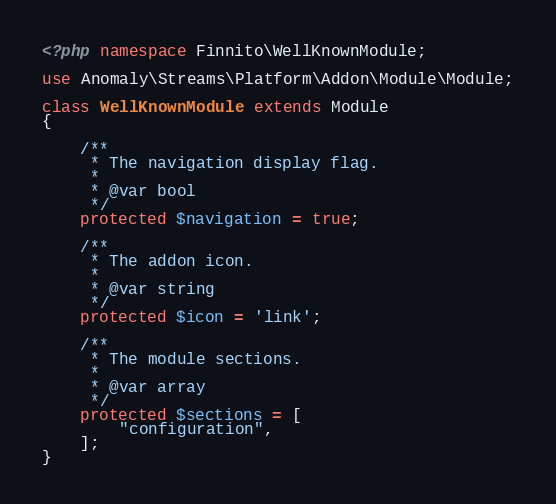Convert code to text. <code><loc_0><loc_0><loc_500><loc_500><_PHP_><?php namespace Finnito\WellKnownModule;

use Anomaly\Streams\Platform\Addon\Module\Module;

class WellKnownModule extends Module
{

    /**
     * The navigation display flag.
     *
     * @var bool
     */
    protected $navigation = true;

    /**
     * The addon icon.
     *
     * @var string
     */
    protected $icon = 'link';

    /**
     * The module sections.
     *
     * @var array
     */
    protected $sections = [
        "configuration",
    ];
}
</code> 